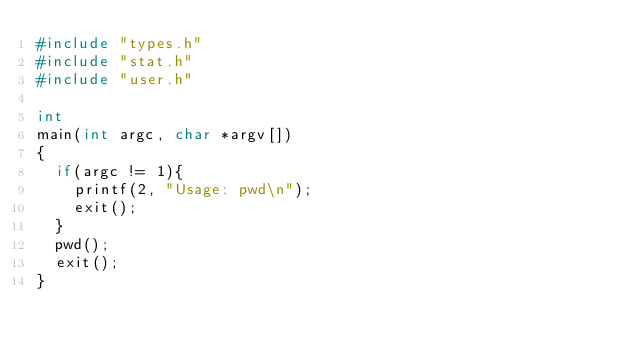Convert code to text. <code><loc_0><loc_0><loc_500><loc_500><_C_>#include "types.h"
#include "stat.h"
#include "user.h"

int
main(int argc, char *argv[])
{
  if(argc != 1){
    printf(2, "Usage: pwd\n");
    exit();
  }
  pwd();
  exit();
}
</code> 